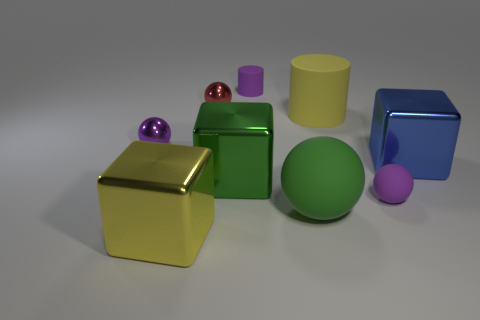Add 1 tiny purple matte cylinders. How many objects exist? 10 Subtract all cylinders. How many objects are left? 7 Subtract 1 red balls. How many objects are left? 8 Subtract all small cyan metal cylinders. Subtract all green objects. How many objects are left? 7 Add 5 large yellow metallic things. How many large yellow metallic things are left? 6 Add 4 tiny red metal things. How many tiny red metal things exist? 5 